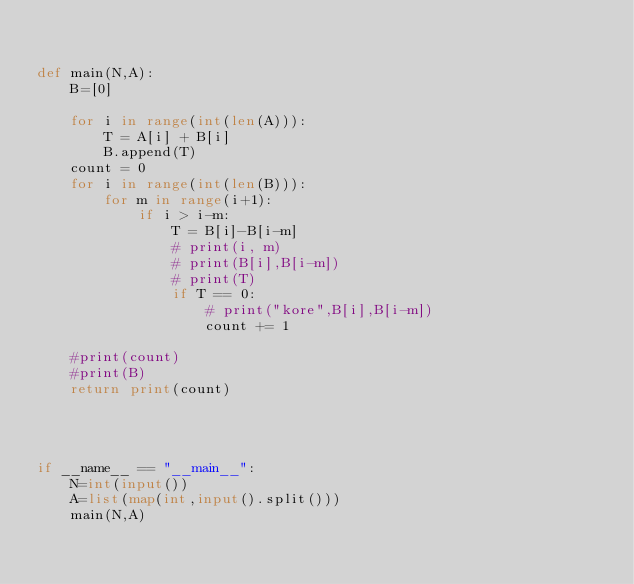<code> <loc_0><loc_0><loc_500><loc_500><_Python_>

def main(N,A):
    B=[0]

    for i in range(int(len(A))):
        T = A[i] + B[i]
        B.append(T)
    count = 0
    for i in range(int(len(B))):
        for m in range(i+1):
            if i > i-m:
                T = B[i]-B[i-m]
                # print(i, m)
                # print(B[i],B[i-m])
                # print(T)
                if T == 0:
                    # print("kore",B[i],B[i-m])
                    count += 1

    #print(count)
    #print(B)
    return print(count)




if __name__ == "__main__":
    N=int(input())
    A=list(map(int,input().split()))
    main(N,A)</code> 